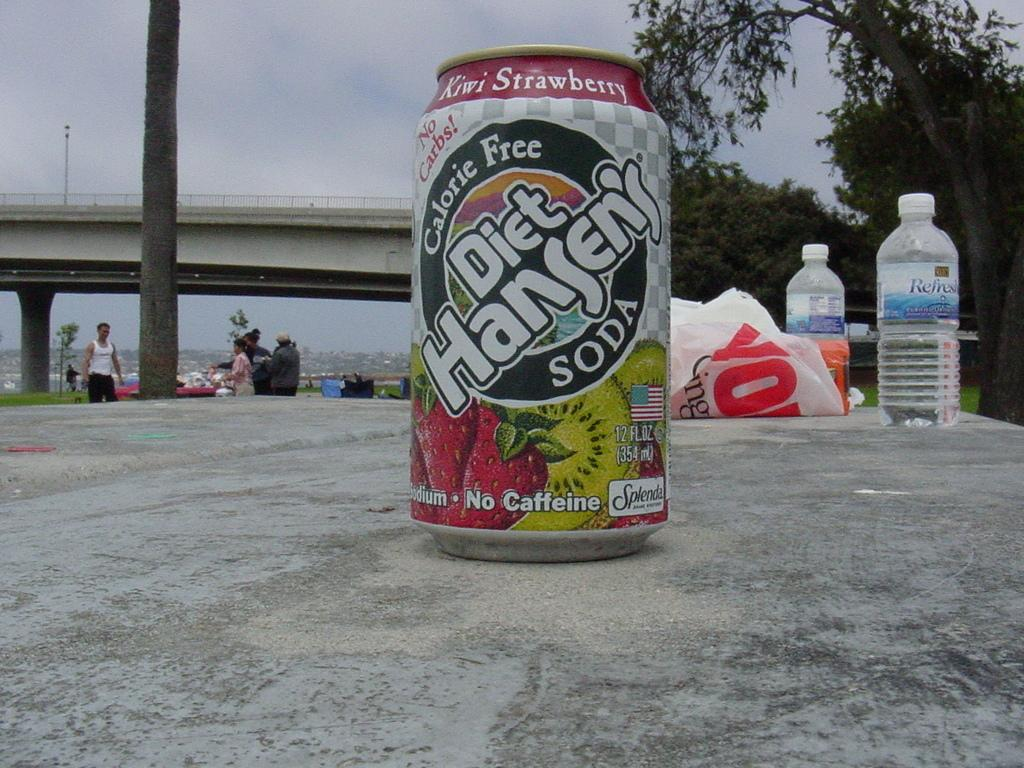Provide a one-sentence caption for the provided image. a diet handens soda on a gray surface outside. 